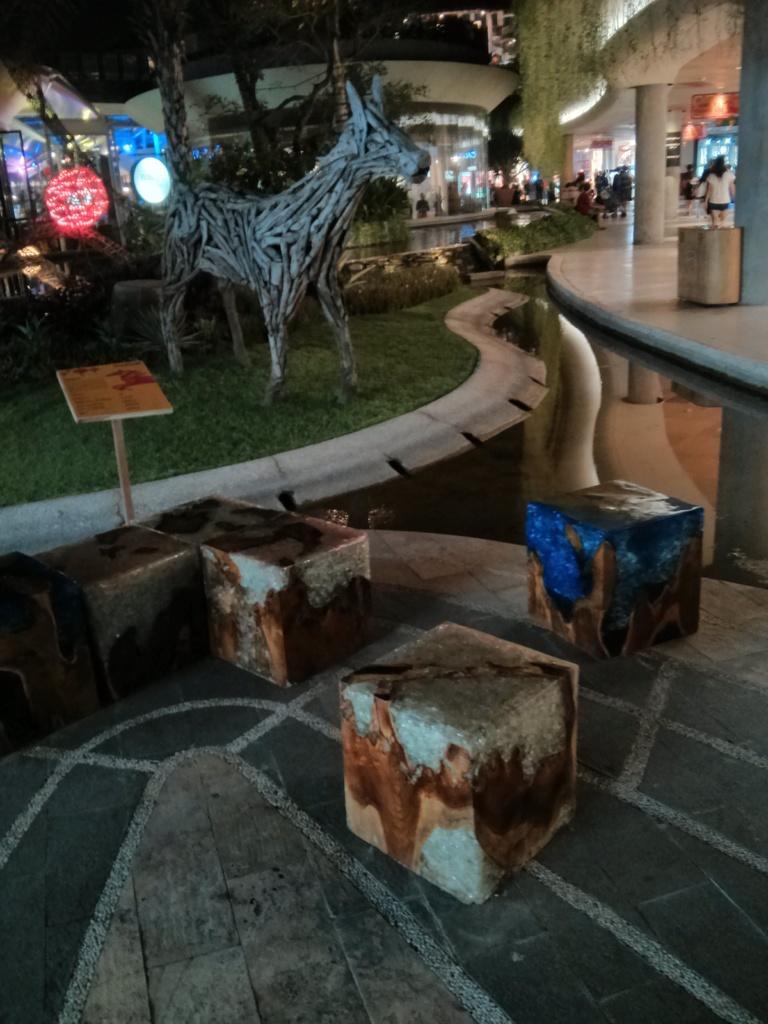Could you give a brief overview of what you see in this image? In this image at the bottom there are some boxes and one board, and in the center there is one toy, and trees, lights, grass and some plants. And in the background there are some buildings and some people are walking and there is one dustbin. On the right side, at the bottom there is a floor. 